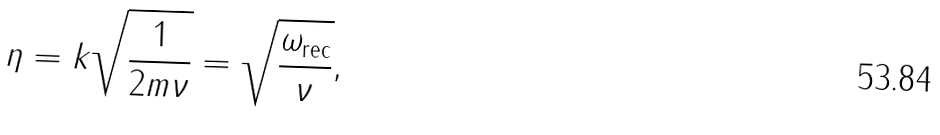Convert formula to latex. <formula><loc_0><loc_0><loc_500><loc_500>\eta = k \sqrt { \frac { 1 } { 2 m \nu } } = \sqrt { \frac { \omega _ { \text {rec} } } { \nu } } ,</formula> 